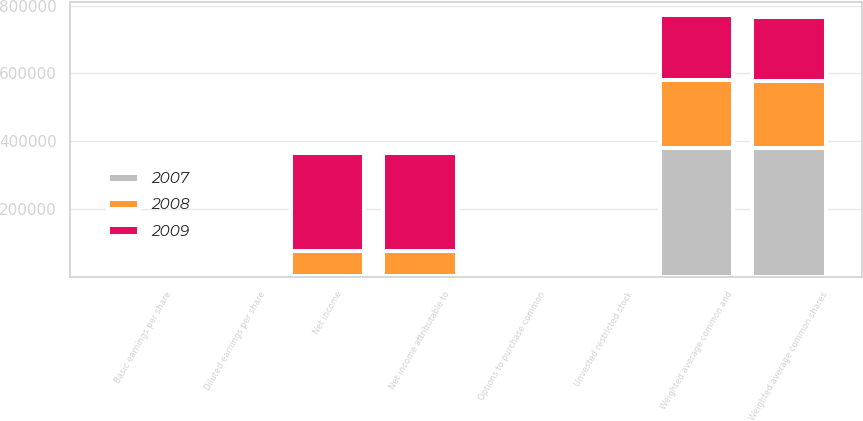Convert chart to OTSL. <chart><loc_0><loc_0><loc_500><loc_500><stacked_bar_chart><ecel><fcel>Net income<fcel>Weighted average common shares<fcel>Basic earnings per share<fcel>Net income attributable to<fcel>Options to purchase common<fcel>Unvested restricted stock<fcel>Weighted average common and<fcel>Diluted earnings per share<nl><fcel>2007<fcel>1785<fcel>379749<fcel>1.3<fcel>1785<fcel>1172<fcel>40<fcel>380961<fcel>1.3<nl><fcel>2008<fcel>73800<fcel>196703<fcel>0.38<fcel>73800<fcel>1646<fcel>2<fcel>198351<fcel>0.37<nl><fcel>2009<fcel>290200<fcel>190103<fcel>1.53<fcel>290200<fcel>1924<fcel>3<fcel>192030<fcel>1.51<nl></chart> 